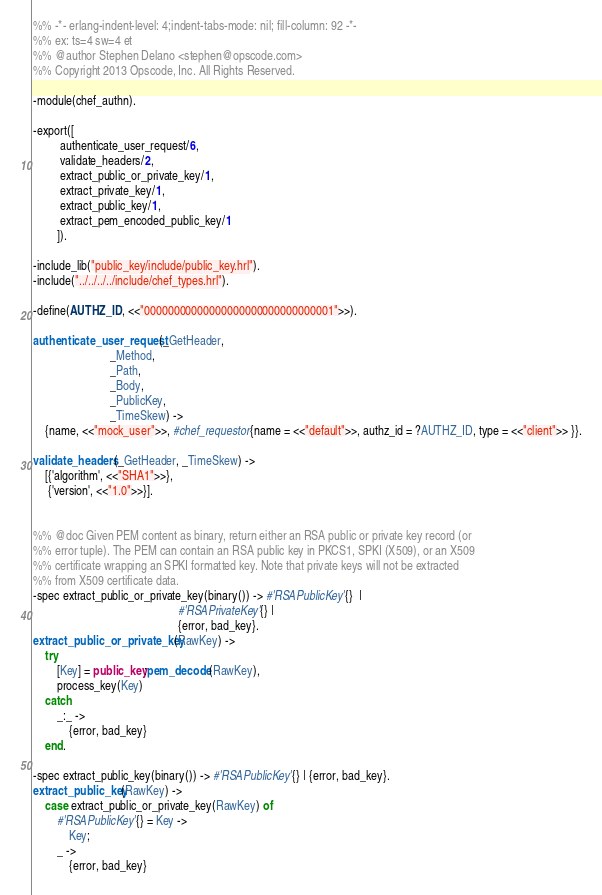Convert code to text. <code><loc_0><loc_0><loc_500><loc_500><_Erlang_>%% -*- erlang-indent-level: 4;indent-tabs-mode: nil; fill-column: 92 -*-
%% ex: ts=4 sw=4 et
%% @author Stephen Delano <stephen@opscode.com>
%% Copyright 2013 Opscode, Inc. All Rights Reserved.

-module(chef_authn).

-export([
         authenticate_user_request/6,
         validate_headers/2,
         extract_public_or_private_key/1,
         extract_private_key/1,
         extract_public_key/1,
         extract_pem_encoded_public_key/1
        ]).

-include_lib("public_key/include/public_key.hrl").
-include("../../../../include/chef_types.hrl").

-define(AUTHZ_ID, <<"00000000000000000000000000000001">>).

authenticate_user_request(_GetHeader,
                          _Method,
                          _Path,
                          _Body,
                          _PublicKey,
                          _TimeSkew) ->
    {name, <<"mock_user">>, #chef_requestor{name = <<"default">>, authz_id = ?AUTHZ_ID, type = <<"client">> }}.

validate_headers(_GetHeader, _TimeSkew) ->
    [{'algorithm', <<"SHA1">>},
     {'version', <<"1.0">>}].


%% @doc Given PEM content as binary, return either an RSA public or private key record (or
%% error tuple). The PEM can contain an RSA public key in PKCS1, SPKI (X509), or an X509
%% certificate wrapping an SPKI formatted key. Note that private keys will not be extracted
%% from X509 certificate data.
-spec extract_public_or_private_key(binary()) -> #'RSAPublicKey'{}  |
                                                 #'RSAPrivateKey'{} |
                                                 {error, bad_key}.
extract_public_or_private_key(RawKey) ->
    try
        [Key] = public_key:pem_decode(RawKey),
        process_key(Key)
    catch
        _:_ ->
            {error, bad_key}
    end.

-spec extract_public_key(binary()) -> #'RSAPublicKey'{} | {error, bad_key}.
extract_public_key(RawKey) ->
    case extract_public_or_private_key(RawKey) of
        #'RSAPublicKey'{} = Key ->
            Key;
        _ ->
            {error, bad_key}</code> 